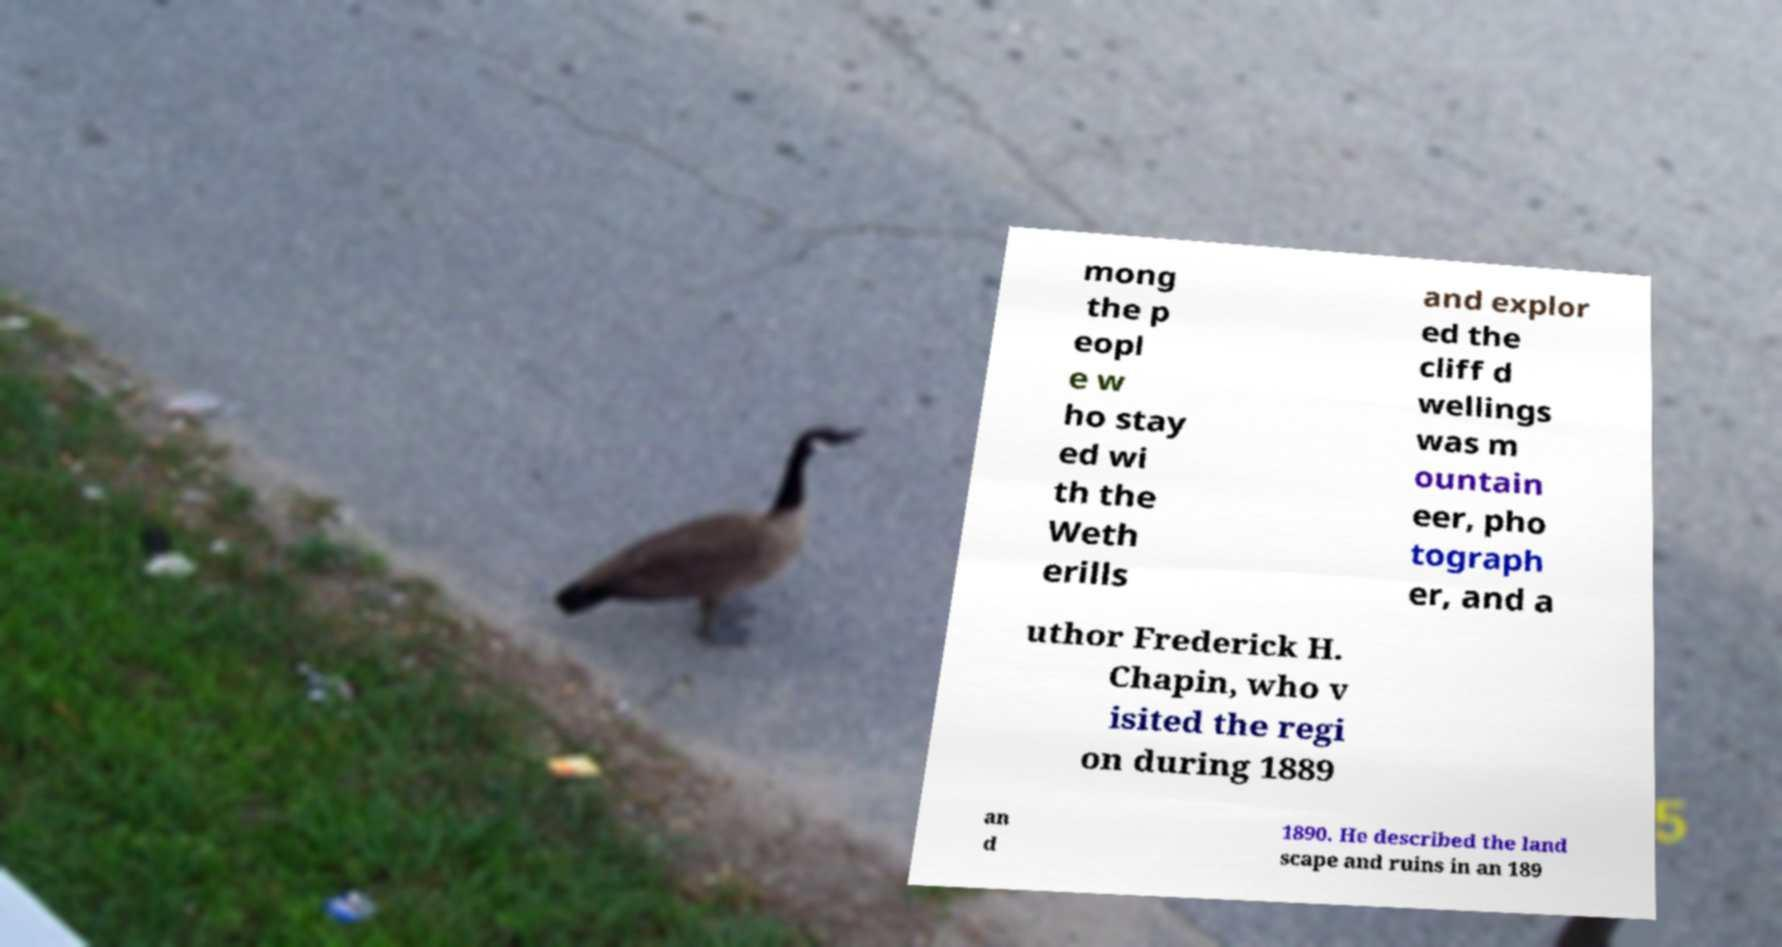What messages or text are displayed in this image? I need them in a readable, typed format. mong the p eopl e w ho stay ed wi th the Weth erills and explor ed the cliff d wellings was m ountain eer, pho tograph er, and a uthor Frederick H. Chapin, who v isited the regi on during 1889 an d 1890. He described the land scape and ruins in an 189 